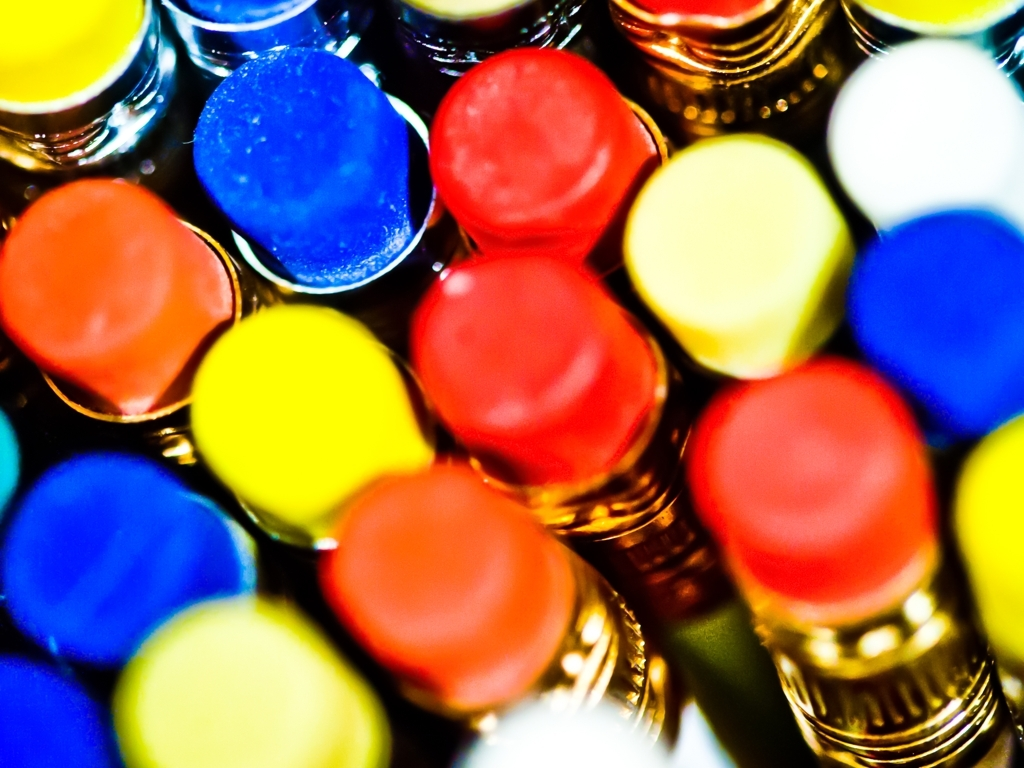Is there a potential commercial use for this image? This image has significant commercial appeal, potentially for use in advertising art supplies, educational materials, or any creative service where color is a key element. Its ability to grab attention with its bold colors could enhance visual marketing campaigns or even serve as an engaging background for graphic design projects. 